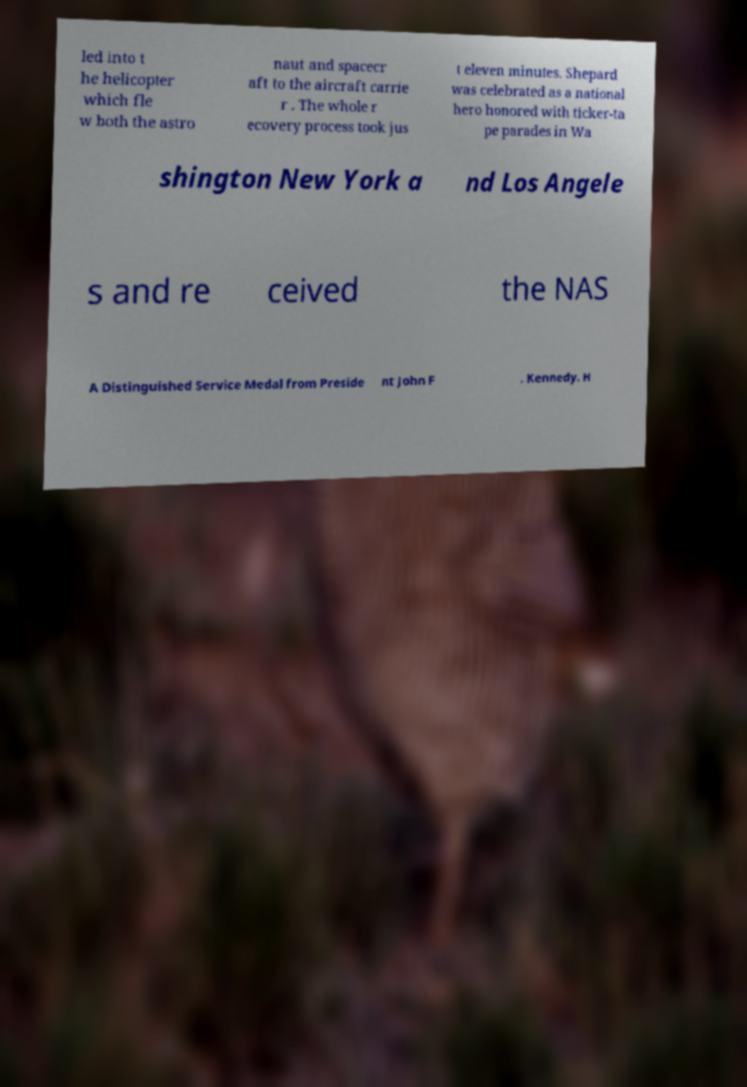For documentation purposes, I need the text within this image transcribed. Could you provide that? led into t he helicopter which fle w both the astro naut and spacecr aft to the aircraft carrie r . The whole r ecovery process took jus t eleven minutes. Shepard was celebrated as a national hero honored with ticker-ta pe parades in Wa shington New York a nd Los Angele s and re ceived the NAS A Distinguished Service Medal from Preside nt John F . Kennedy. H 